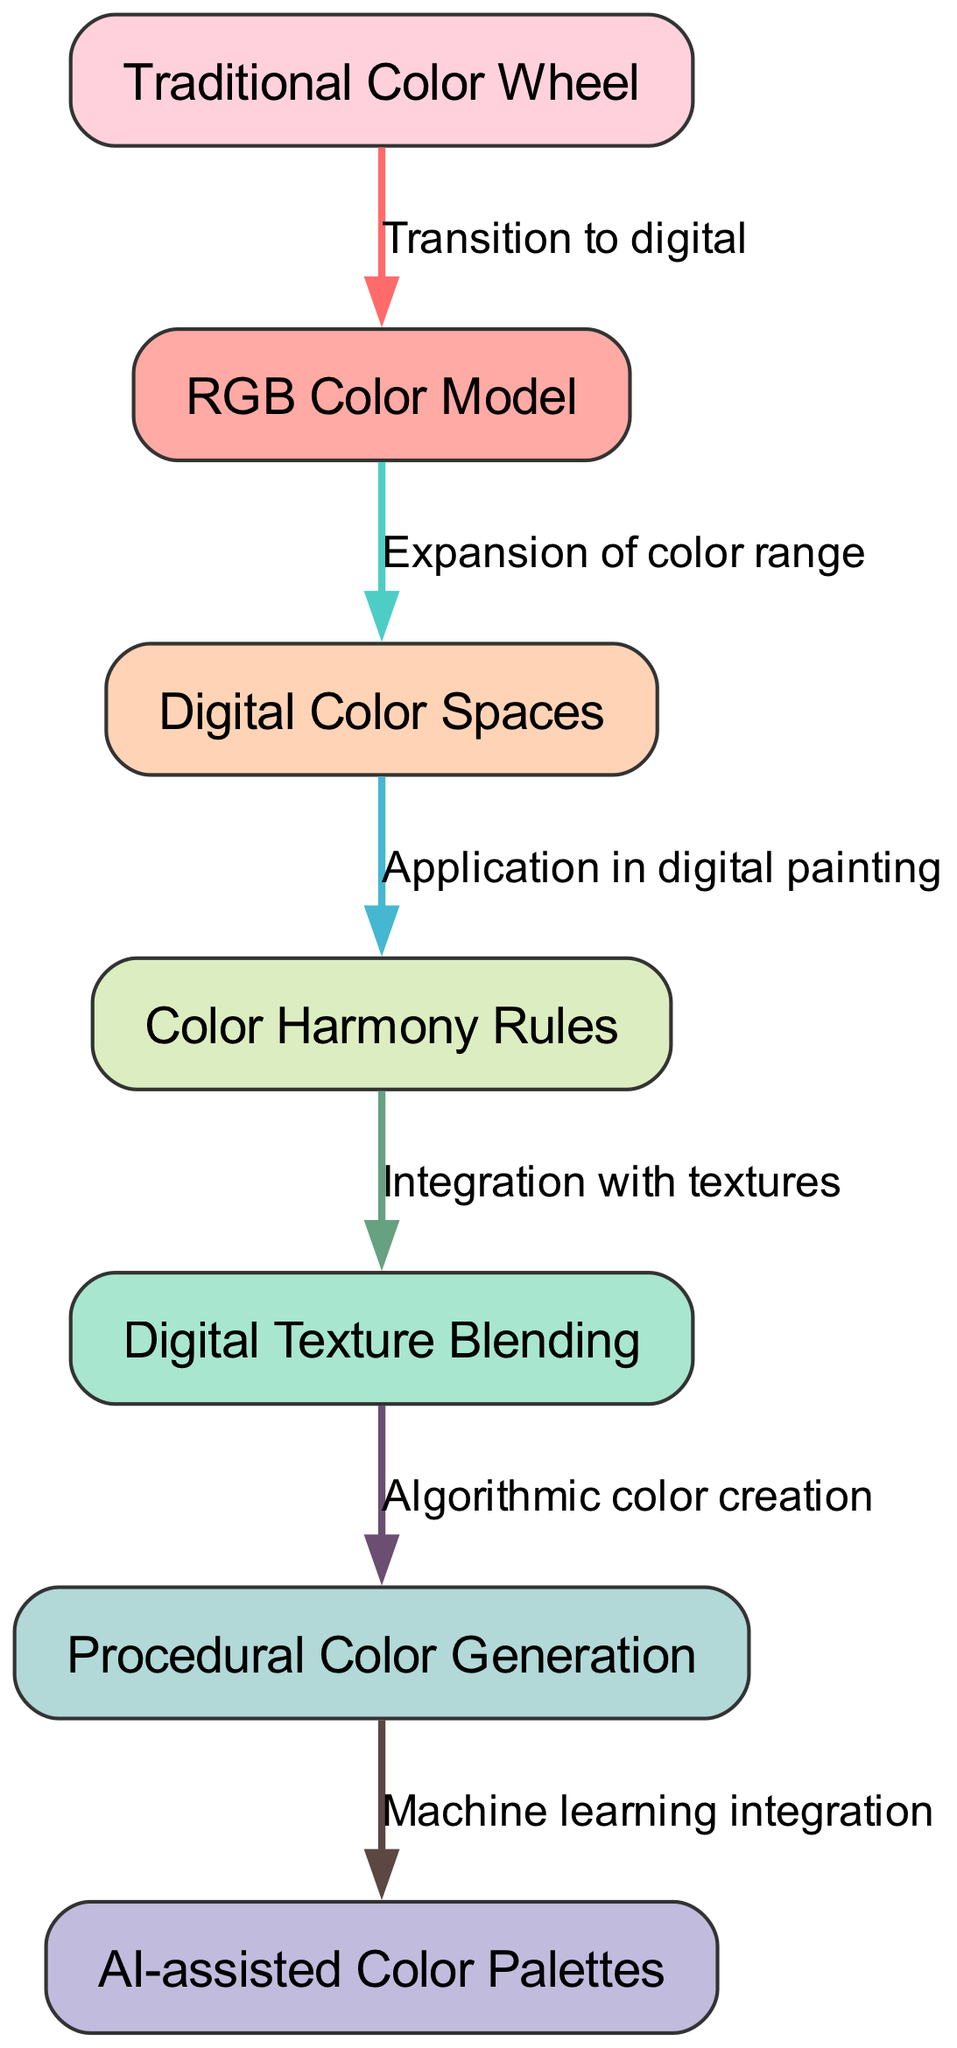What is the first node in the flowchart? The first node is labeled "Traditional Color Wheel," which is the starting point of the evolution of color theory in the diagram.
Answer: Traditional Color Wheel How many nodes are present in the diagram? There are a total of 7 nodes listed in the diagram representing different aspects of color theory evolution.
Answer: 7 What transition occurs between the first and second nodes? The edge label indicates a "Transition to digital," which shows the movement from traditional methods to digital techniques in color theory.
Answer: Transition to digital Which node is linked to both the "Digital Color Spaces" and "Color Harmony Rules"? The node labeled "Digital Color Spaces" is linked directly to "Color Harmony Rules" according to the diagram's flow.
Answer: Color Harmony Rules What process is indicated after "Digital Texture Blending"? According to the diagram, the process indicated after "Digital Texture Blending" is "Algorithmic color creation," showing an advancement in color mixing techniques.
Answer: Algorithmic color creation How does the "RGB Color Model" relate to the "Digital Color Spaces"? The label on the edge connecting "RGB Color Model" and "Digital Color Spaces" states "Expansion of color range," which suggests that the RGB model enriches the options available in digital spaces.
Answer: Expansion of color range What technological integration follows the "Procedural Color Generation"? The arrow leads to a node labeled "AI-assisted Color Palettes," indicating that procedural generation is enhanced by the use of machine learning technology.
Answer: AI-assisted Color Palettes 